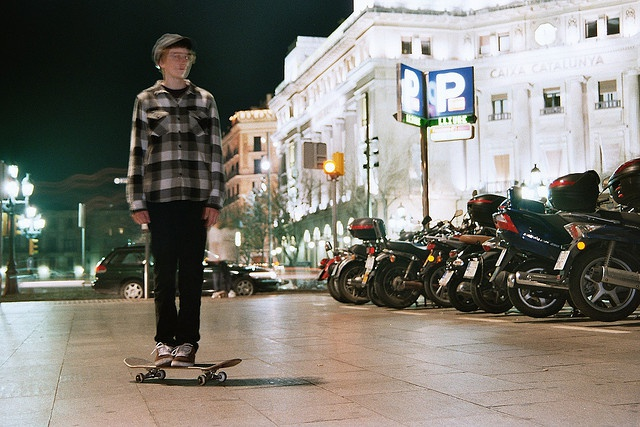Describe the objects in this image and their specific colors. I can see people in black, gray, and maroon tones, motorcycle in black, gray, and darkgray tones, motorcycle in black and gray tones, car in black, gray, and lightgray tones, and motorcycle in black, gray, and lightgray tones in this image. 